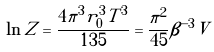<formula> <loc_0><loc_0><loc_500><loc_500>\ln Z = \frac { 4 \pi ^ { 3 } r _ { 0 } ^ { 3 } T ^ { 3 } } { 1 3 5 } = \frac { \pi ^ { 2 } } { 4 5 } \beta ^ { - 3 } V</formula> 